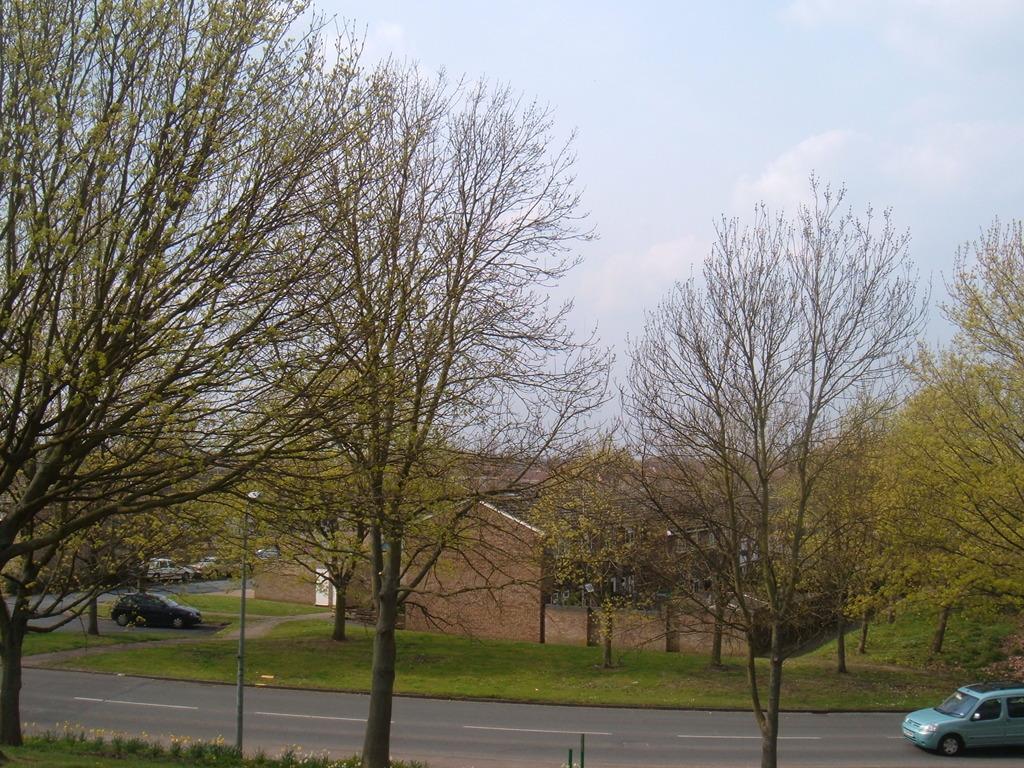In one or two sentences, can you explain what this image depicts? In this picture I can see vehicles on the road, there is a building, there are trees, and in the background there is the sky. 